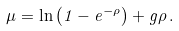Convert formula to latex. <formula><loc_0><loc_0><loc_500><loc_500>\mu = \ln \left ( 1 - e ^ { - \rho } \right ) + g \rho \, .</formula> 